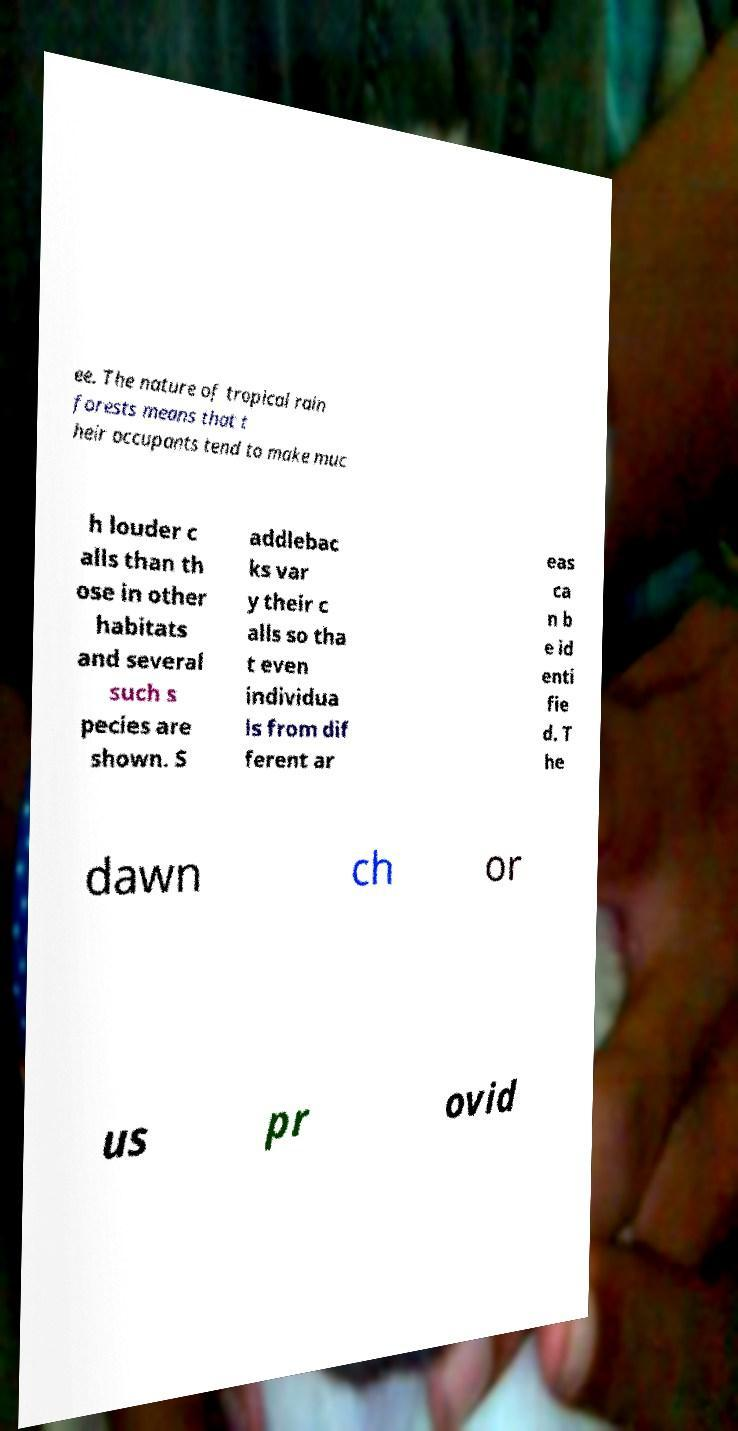What messages or text are displayed in this image? I need them in a readable, typed format. ee. The nature of tropical rain forests means that t heir occupants tend to make muc h louder c alls than th ose in other habitats and several such s pecies are shown. S addlebac ks var y their c alls so tha t even individua ls from dif ferent ar eas ca n b e id enti fie d. T he dawn ch or us pr ovid 